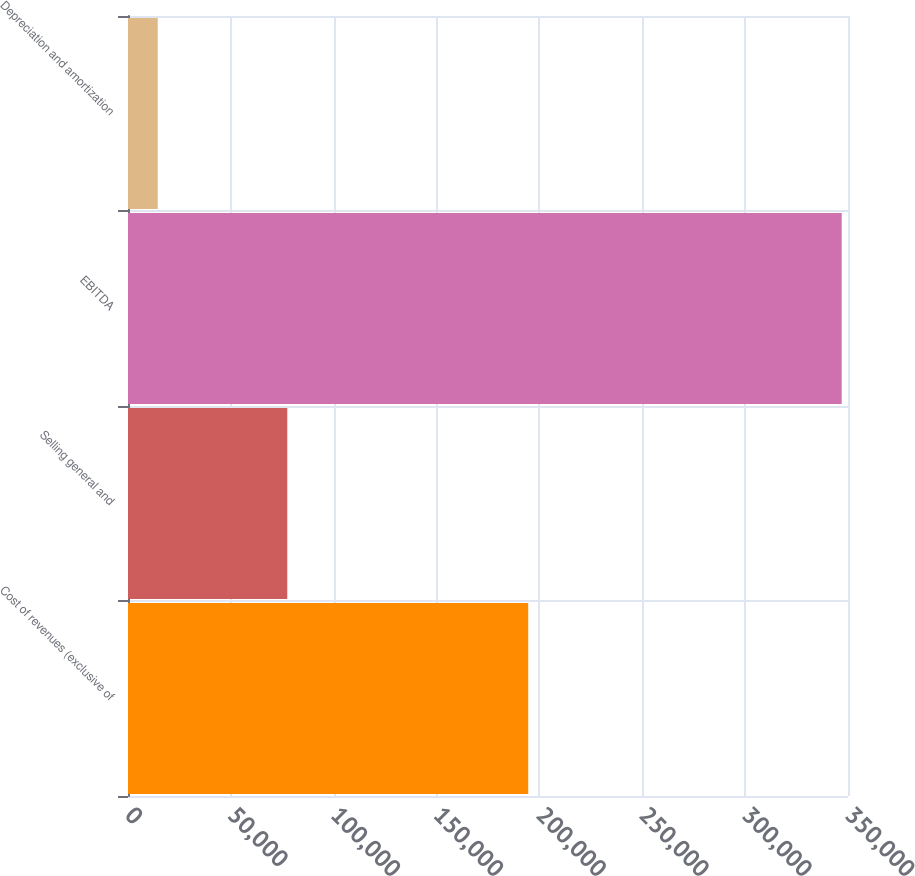Convert chart. <chart><loc_0><loc_0><loc_500><loc_500><bar_chart><fcel>Cost of revenues (exclusive of<fcel>Selling general and<fcel>EBITDA<fcel>Depreciation and amortization<nl><fcel>194545<fcel>77425<fcel>346931<fcel>14451<nl></chart> 